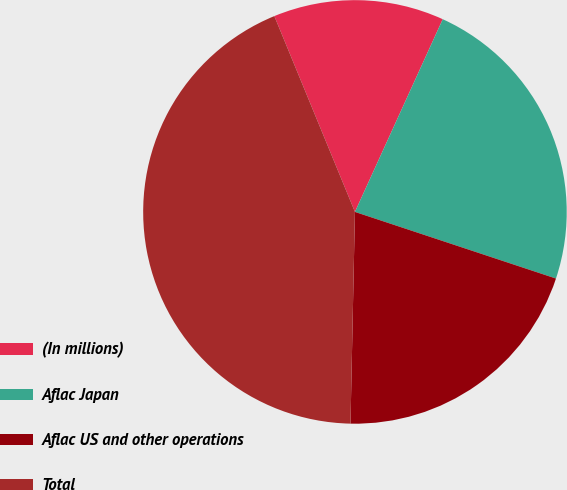Convert chart. <chart><loc_0><loc_0><loc_500><loc_500><pie_chart><fcel>(In millions)<fcel>Aflac Japan<fcel>Aflac US and other operations<fcel>Total<nl><fcel>13.02%<fcel>23.29%<fcel>20.24%<fcel>43.45%<nl></chart> 